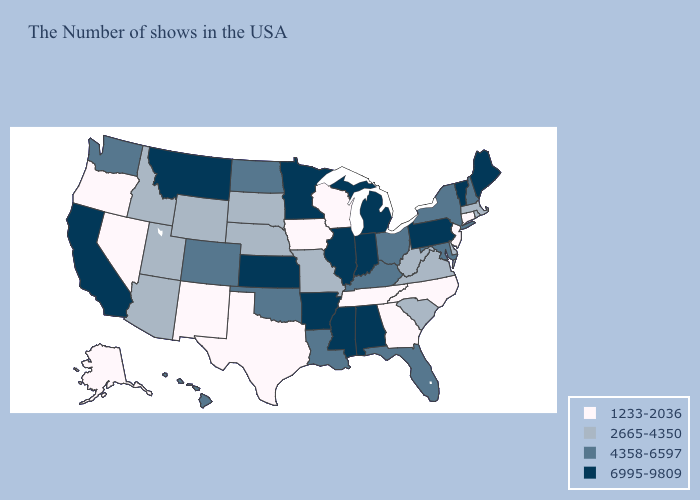What is the value of California?
Short answer required. 6995-9809. Does the first symbol in the legend represent the smallest category?
Keep it brief. Yes. What is the highest value in states that border Washington?
Be succinct. 2665-4350. Name the states that have a value in the range 4358-6597?
Be succinct. New Hampshire, New York, Maryland, Ohio, Florida, Kentucky, Louisiana, Oklahoma, North Dakota, Colorado, Washington, Hawaii. Among the states that border North Dakota , does South Dakota have the highest value?
Write a very short answer. No. What is the value of Massachusetts?
Keep it brief. 2665-4350. What is the value of North Dakota?
Short answer required. 4358-6597. What is the value of New York?
Concise answer only. 4358-6597. What is the value of Connecticut?
Give a very brief answer. 1233-2036. What is the value of Iowa?
Write a very short answer. 1233-2036. Among the states that border Delaware , which have the highest value?
Concise answer only. Pennsylvania. What is the highest value in the USA?
Short answer required. 6995-9809. What is the value of New Mexico?
Short answer required. 1233-2036. 